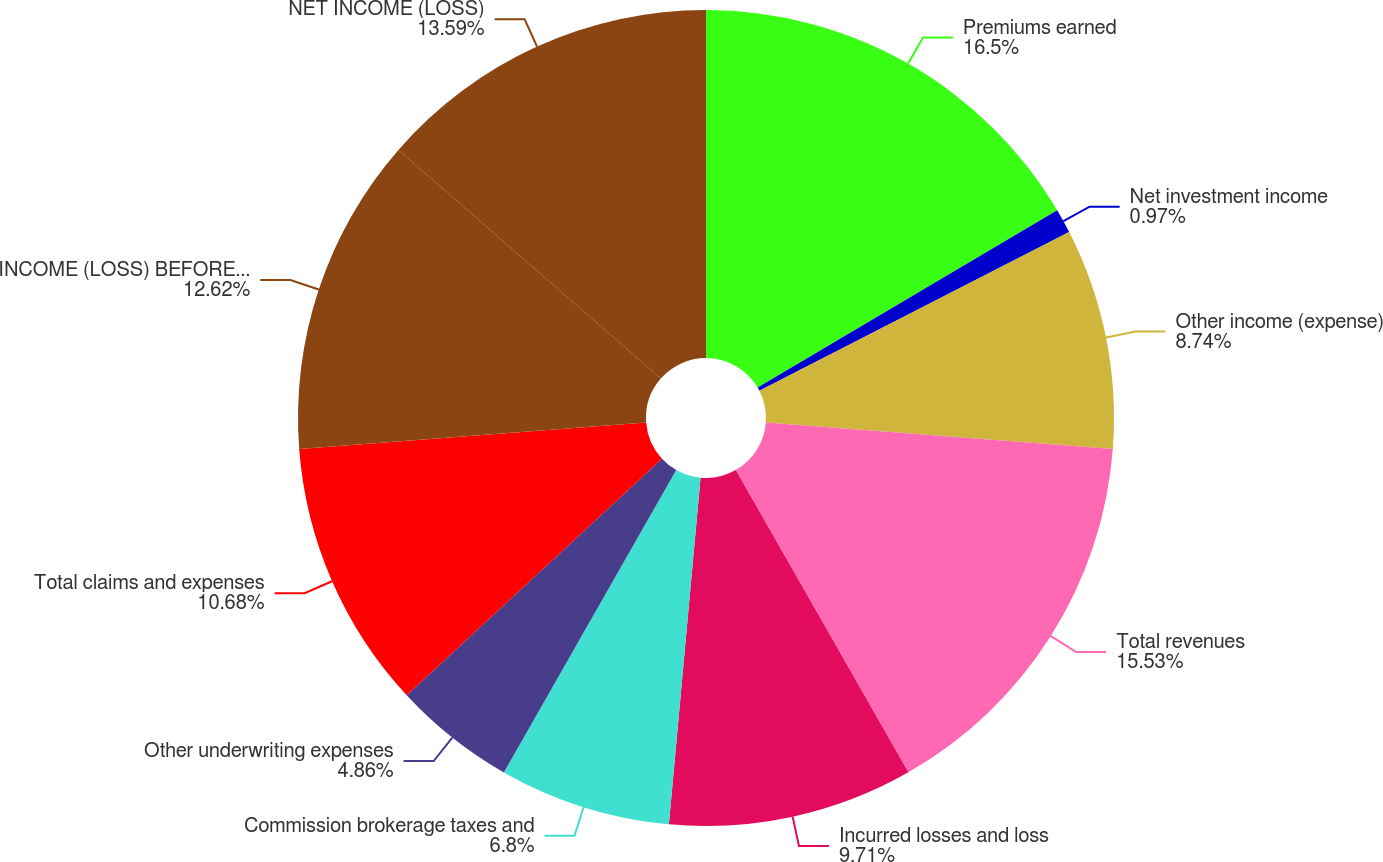<chart> <loc_0><loc_0><loc_500><loc_500><pie_chart><fcel>Premiums earned<fcel>Net investment income<fcel>Other income (expense)<fcel>Total revenues<fcel>Incurred losses and loss<fcel>Commission brokerage taxes and<fcel>Other underwriting expenses<fcel>Total claims and expenses<fcel>INCOME (LOSS) BEFORE TAXES<fcel>NET INCOME (LOSS)<nl><fcel>16.5%<fcel>0.97%<fcel>8.74%<fcel>15.53%<fcel>9.71%<fcel>6.8%<fcel>4.86%<fcel>10.68%<fcel>12.62%<fcel>13.59%<nl></chart> 